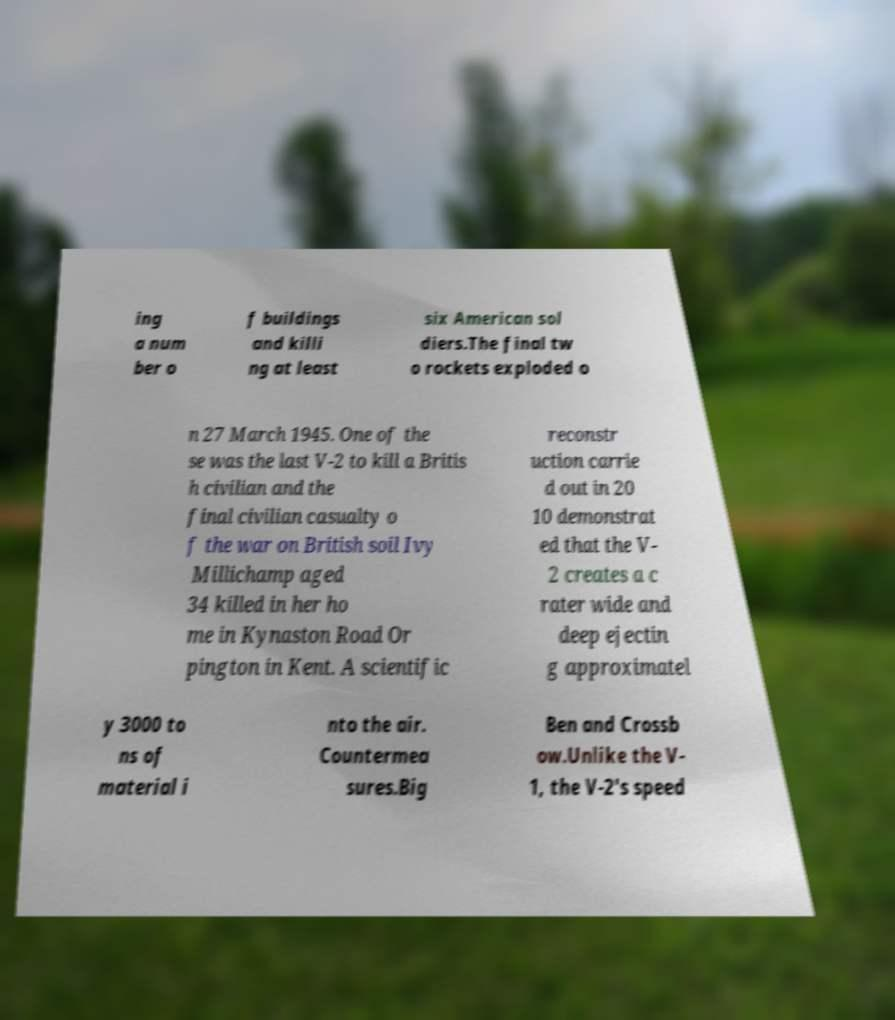Please read and relay the text visible in this image. What does it say? ing a num ber o f buildings and killi ng at least six American sol diers.The final tw o rockets exploded o n 27 March 1945. One of the se was the last V-2 to kill a Britis h civilian and the final civilian casualty o f the war on British soil Ivy Millichamp aged 34 killed in her ho me in Kynaston Road Or pington in Kent. A scientific reconstr uction carrie d out in 20 10 demonstrat ed that the V- 2 creates a c rater wide and deep ejectin g approximatel y 3000 to ns of material i nto the air. Countermea sures.Big Ben and Crossb ow.Unlike the V- 1, the V-2's speed 